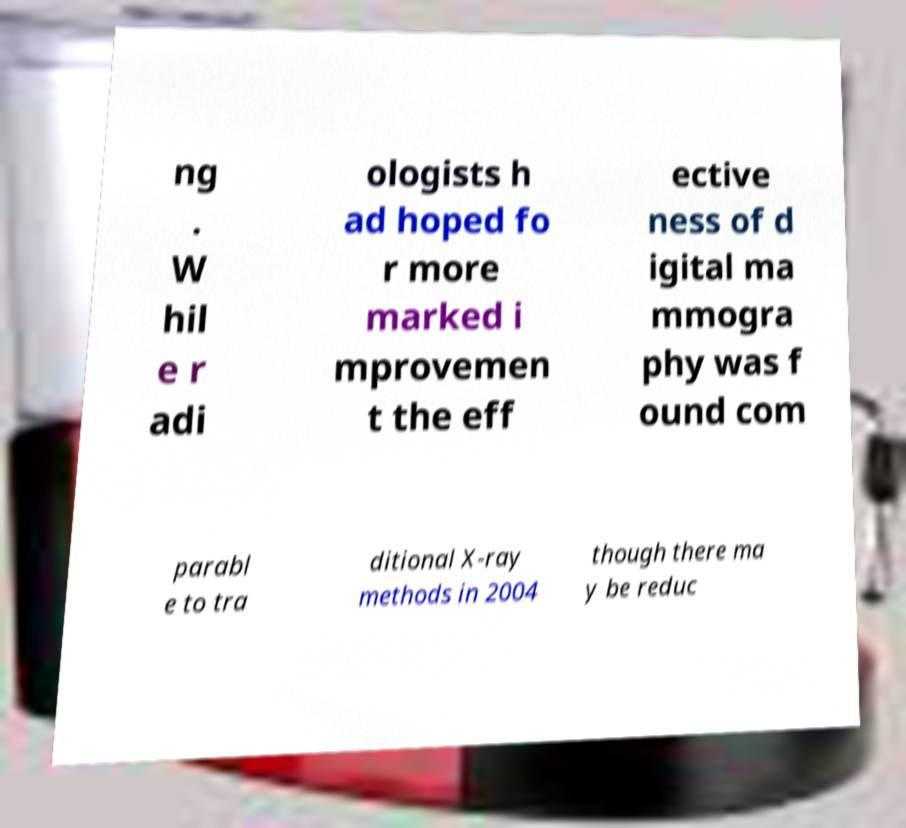Can you read and provide the text displayed in the image?This photo seems to have some interesting text. Can you extract and type it out for me? ng . W hil e r adi ologists h ad hoped fo r more marked i mprovemen t the eff ective ness of d igital ma mmogra phy was f ound com parabl e to tra ditional X-ray methods in 2004 though there ma y be reduc 